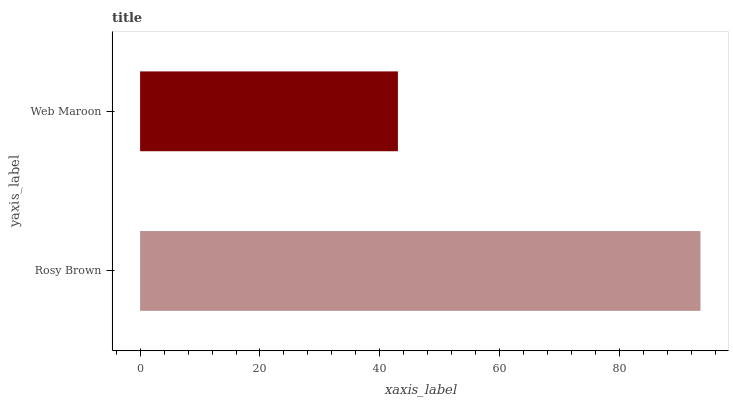Is Web Maroon the minimum?
Answer yes or no. Yes. Is Rosy Brown the maximum?
Answer yes or no. Yes. Is Web Maroon the maximum?
Answer yes or no. No. Is Rosy Brown greater than Web Maroon?
Answer yes or no. Yes. Is Web Maroon less than Rosy Brown?
Answer yes or no. Yes. Is Web Maroon greater than Rosy Brown?
Answer yes or no. No. Is Rosy Brown less than Web Maroon?
Answer yes or no. No. Is Rosy Brown the high median?
Answer yes or no. Yes. Is Web Maroon the low median?
Answer yes or no. Yes. Is Web Maroon the high median?
Answer yes or no. No. Is Rosy Brown the low median?
Answer yes or no. No. 